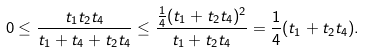Convert formula to latex. <formula><loc_0><loc_0><loc_500><loc_500>0 \leq \frac { t _ { 1 } t _ { 2 } t _ { 4 } } { t _ { 1 } + t _ { 4 } + t _ { 2 } t _ { 4 } } \leq \frac { \frac { 1 } { 4 } ( t _ { 1 } + t _ { 2 } t _ { 4 } ) ^ { 2 } } { t _ { 1 } + t _ { 2 } t _ { 4 } } = \frac { 1 } { 4 } ( t _ { 1 } + t _ { 2 } t _ { 4 } ) .</formula> 